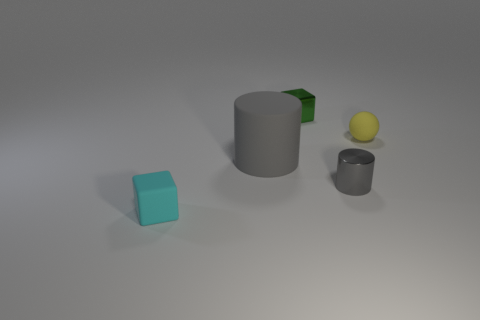Add 5 gray cylinders. How many objects exist? 10 Subtract all balls. How many objects are left? 4 Add 3 small balls. How many small balls are left? 4 Add 5 small balls. How many small balls exist? 6 Subtract 0 green balls. How many objects are left? 5 Subtract 1 cylinders. How many cylinders are left? 1 Subtract all green blocks. Subtract all red spheres. How many blocks are left? 1 Subtract all cyan cubes. How many brown cylinders are left? 0 Subtract all big objects. Subtract all big gray rubber cylinders. How many objects are left? 3 